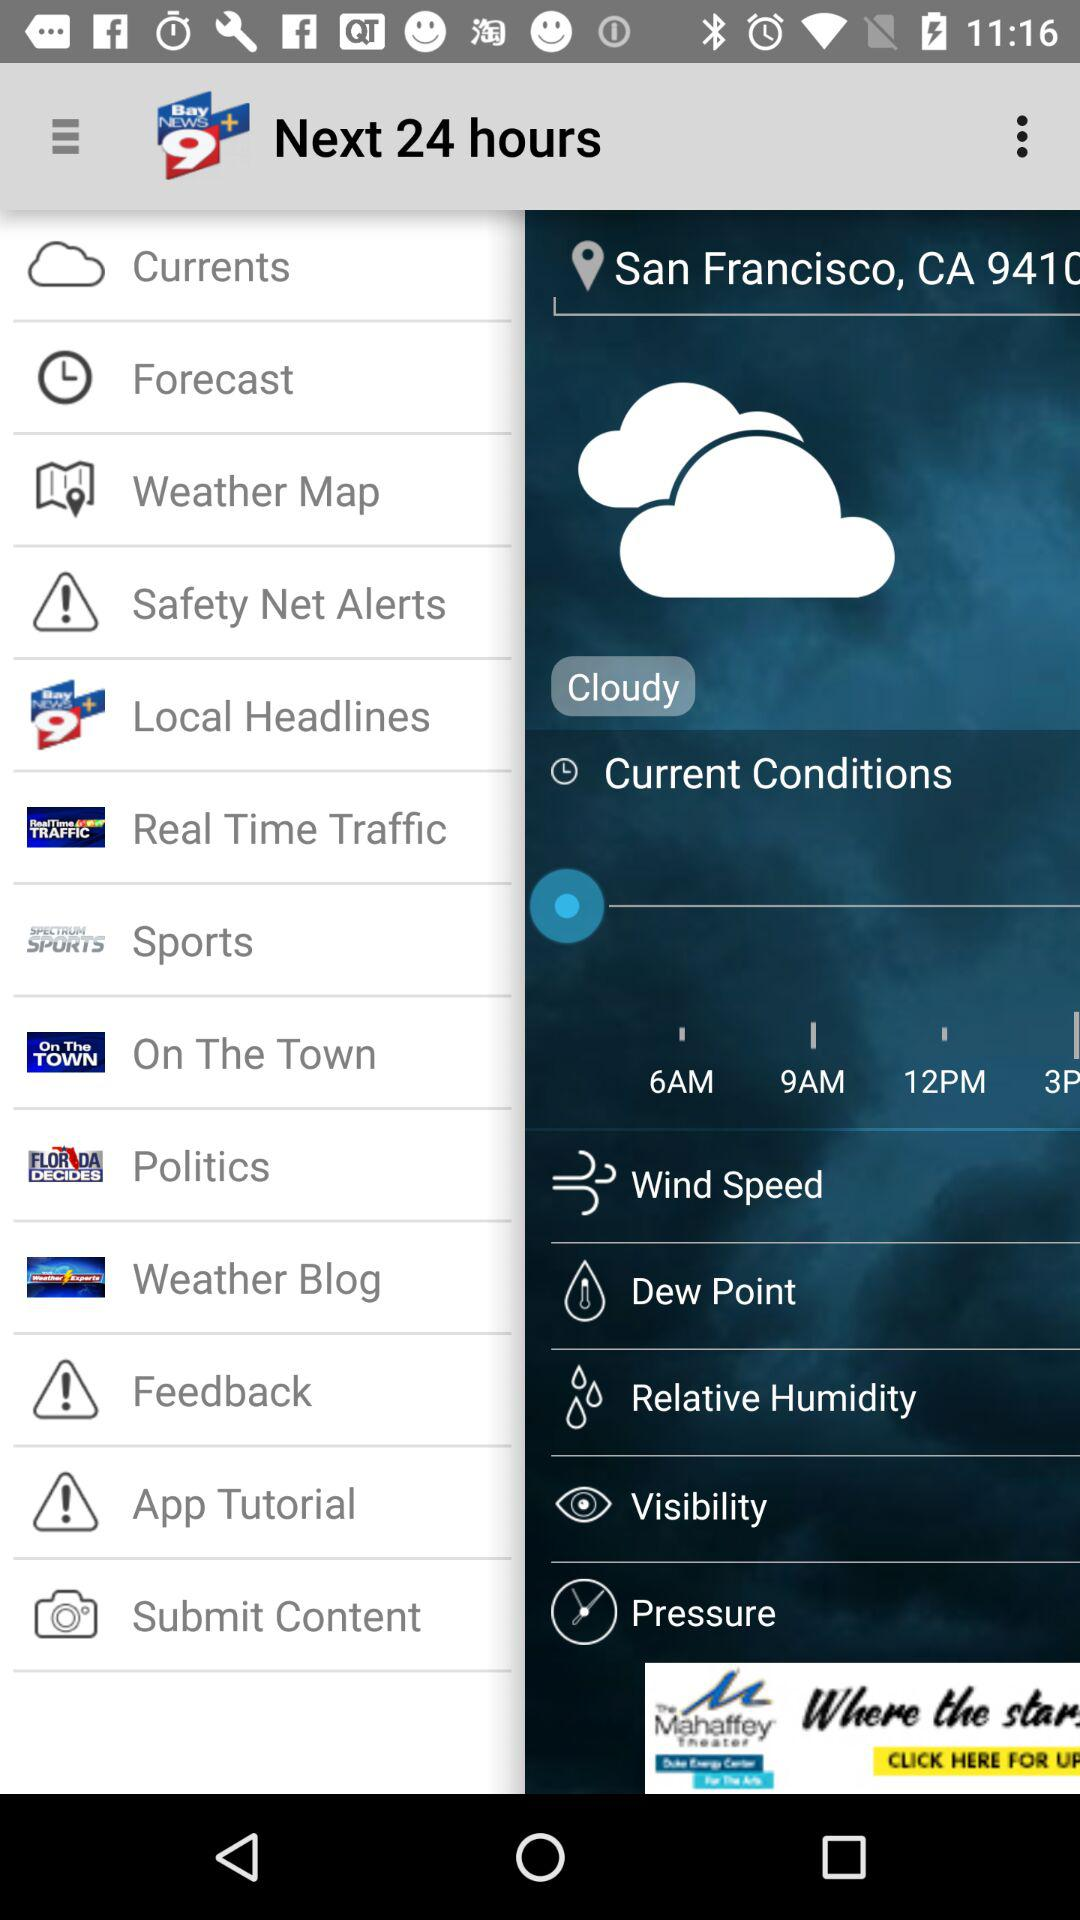How is the weather? The weather is cloudy. 